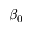Convert formula to latex. <formula><loc_0><loc_0><loc_500><loc_500>\beta _ { 0 }</formula> 